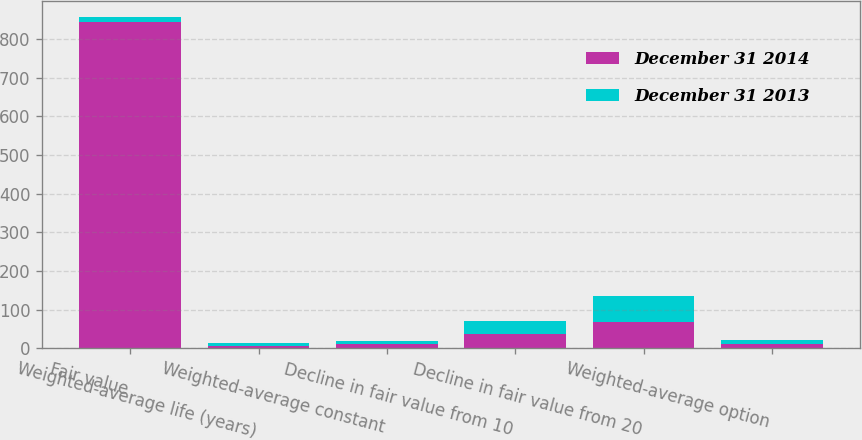Convert chart to OTSL. <chart><loc_0><loc_0><loc_500><loc_500><stacked_bar_chart><ecel><fcel>Fair value<fcel>Weighted-average life (years)<fcel>Weighted-average constant<fcel>Decline in fair value from 10<fcel>Decline in fair value from 20<fcel>Weighted-average option<nl><fcel>December 31 2014<fcel>845<fcel>6.1<fcel>11.16<fcel>36<fcel>69<fcel>10.36<nl><fcel>December 31 2013<fcel>11.16<fcel>7.9<fcel>7.61<fcel>34<fcel>67<fcel>10.24<nl></chart> 